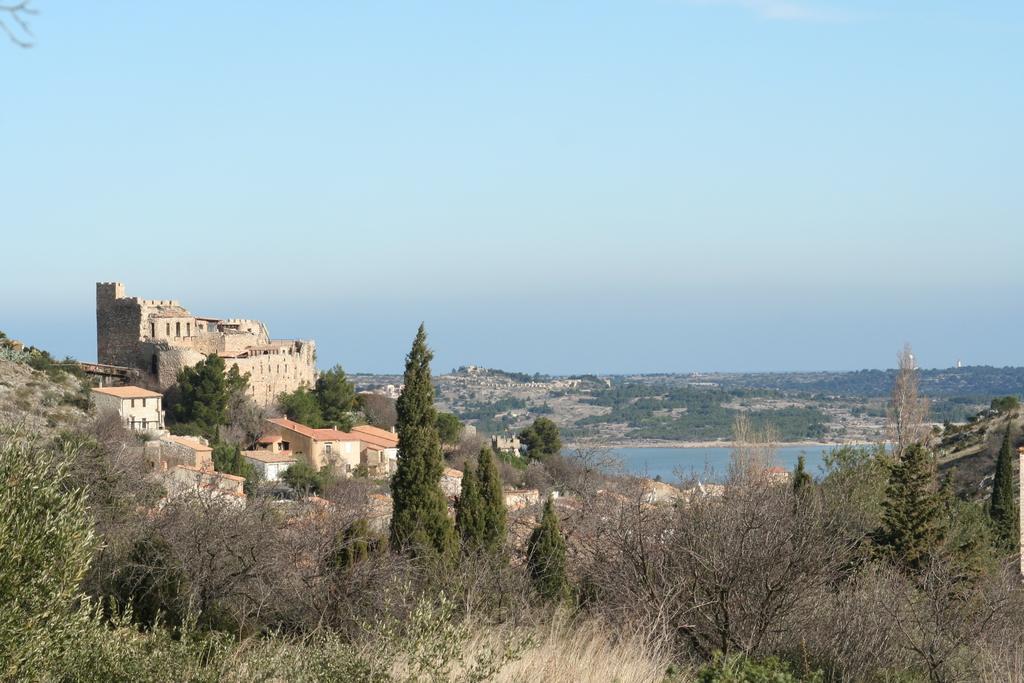Could you give a brief overview of what you see in this image? In this picture there are buildings and trees and there is a mountain. At the top there is sky. At the bottom there is water and there are plants. 